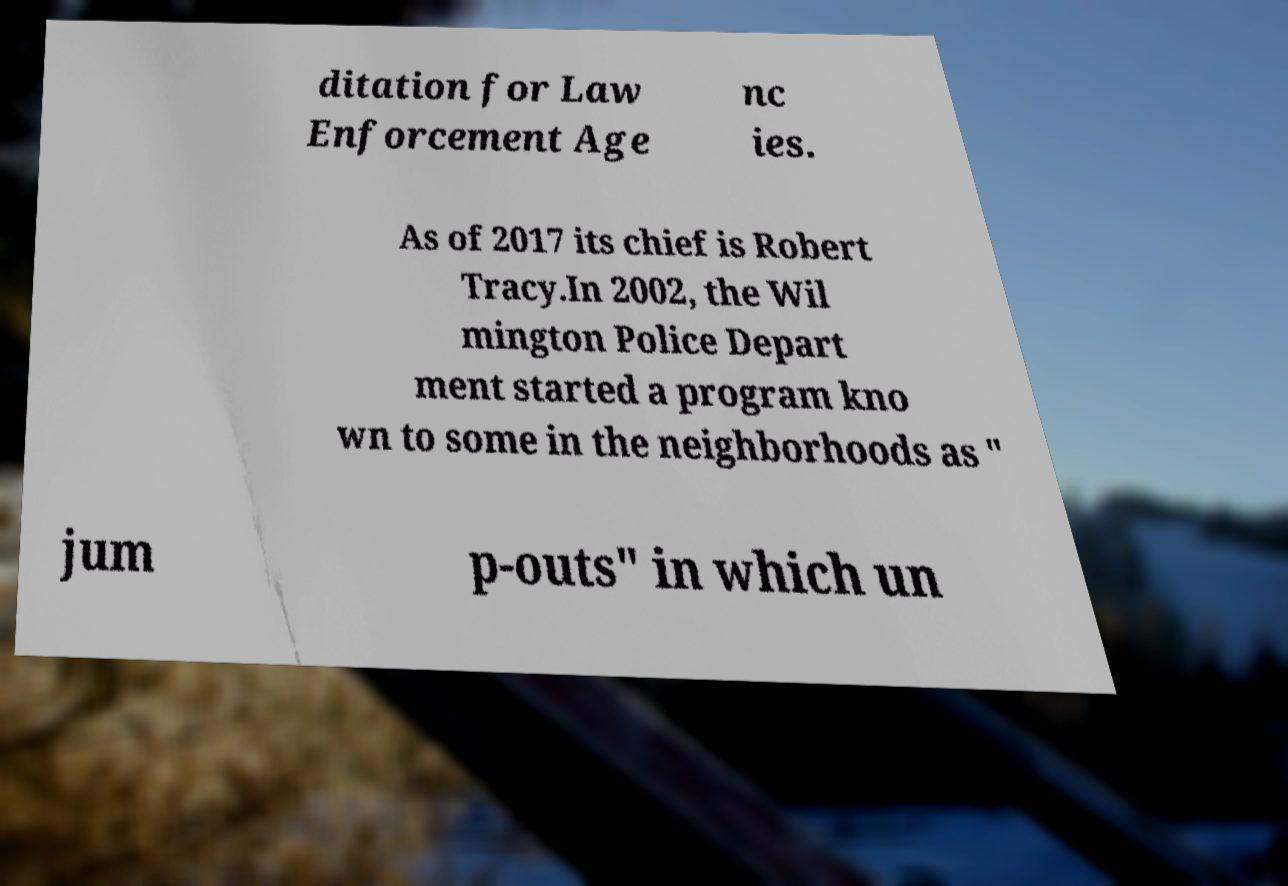For documentation purposes, I need the text within this image transcribed. Could you provide that? ditation for Law Enforcement Age nc ies. As of 2017 its chief is Robert Tracy.In 2002, the Wil mington Police Depart ment started a program kno wn to some in the neighborhoods as " jum p-outs" in which un 